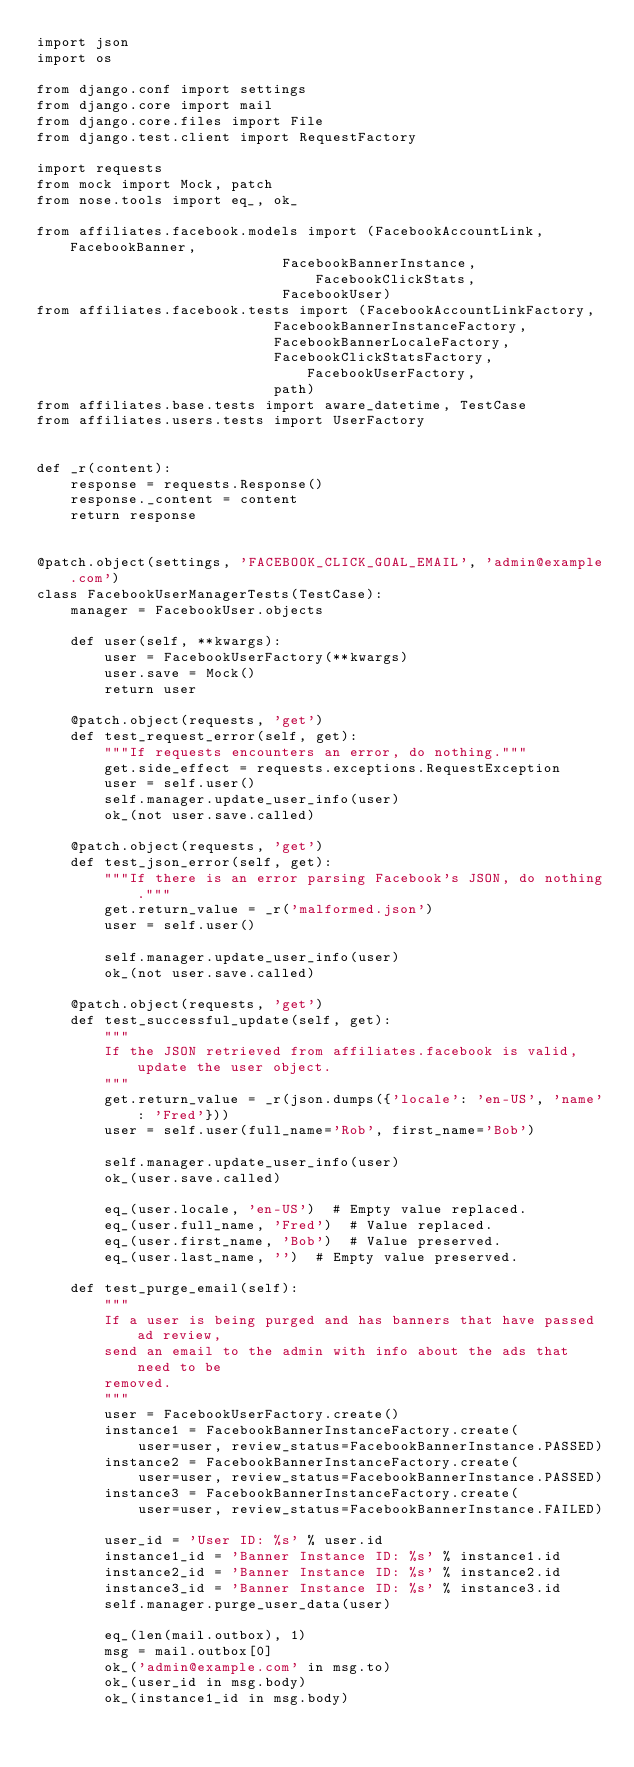Convert code to text. <code><loc_0><loc_0><loc_500><loc_500><_Python_>import json
import os

from django.conf import settings
from django.core import mail
from django.core.files import File
from django.test.client import RequestFactory

import requests
from mock import Mock, patch
from nose.tools import eq_, ok_

from affiliates.facebook.models import (FacebookAccountLink, FacebookBanner,
                             FacebookBannerInstance, FacebookClickStats,
                             FacebookUser)
from affiliates.facebook.tests import (FacebookAccountLinkFactory,
                            FacebookBannerInstanceFactory,
                            FacebookBannerLocaleFactory,
                            FacebookClickStatsFactory, FacebookUserFactory,
                            path)
from affiliates.base.tests import aware_datetime, TestCase
from affiliates.users.tests import UserFactory


def _r(content):
    response = requests.Response()
    response._content = content
    return response


@patch.object(settings, 'FACEBOOK_CLICK_GOAL_EMAIL', 'admin@example.com')
class FacebookUserManagerTests(TestCase):
    manager = FacebookUser.objects

    def user(self, **kwargs):
        user = FacebookUserFactory(**kwargs)
        user.save = Mock()
        return user

    @patch.object(requests, 'get')
    def test_request_error(self, get):
        """If requests encounters an error, do nothing."""
        get.side_effect = requests.exceptions.RequestException
        user = self.user()
        self.manager.update_user_info(user)
        ok_(not user.save.called)

    @patch.object(requests, 'get')
    def test_json_error(self, get):
        """If there is an error parsing Facebook's JSON, do nothing."""
        get.return_value = _r('malformed.json')
        user = self.user()

        self.manager.update_user_info(user)
        ok_(not user.save.called)

    @patch.object(requests, 'get')
    def test_successful_update(self, get):
        """
        If the JSON retrieved from affiliates.facebook is valid, update the user object.
        """
        get.return_value = _r(json.dumps({'locale': 'en-US', 'name': 'Fred'}))
        user = self.user(full_name='Rob', first_name='Bob')

        self.manager.update_user_info(user)
        ok_(user.save.called)

        eq_(user.locale, 'en-US')  # Empty value replaced.
        eq_(user.full_name, 'Fred')  # Value replaced.
        eq_(user.first_name, 'Bob')  # Value preserved.
        eq_(user.last_name, '')  # Empty value preserved.

    def test_purge_email(self):
        """
        If a user is being purged and has banners that have passed ad review,
        send an email to the admin with info about the ads that need to be
        removed.
        """
        user = FacebookUserFactory.create()
        instance1 = FacebookBannerInstanceFactory.create(
            user=user, review_status=FacebookBannerInstance.PASSED)
        instance2 = FacebookBannerInstanceFactory.create(
            user=user, review_status=FacebookBannerInstance.PASSED)
        instance3 = FacebookBannerInstanceFactory.create(
            user=user, review_status=FacebookBannerInstance.FAILED)

        user_id = 'User ID: %s' % user.id
        instance1_id = 'Banner Instance ID: %s' % instance1.id
        instance2_id = 'Banner Instance ID: %s' % instance2.id
        instance3_id = 'Banner Instance ID: %s' % instance3.id
        self.manager.purge_user_data(user)

        eq_(len(mail.outbox), 1)
        msg = mail.outbox[0]
        ok_('admin@example.com' in msg.to)
        ok_(user_id in msg.body)
        ok_(instance1_id in msg.body)</code> 